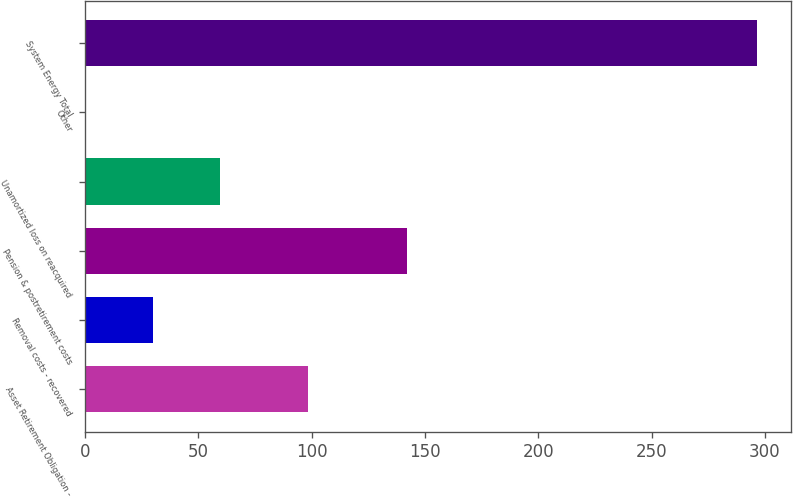Convert chart to OTSL. <chart><loc_0><loc_0><loc_500><loc_500><bar_chart><fcel>Asset Retirement Obligation -<fcel>Removal costs - recovered<fcel>Pension & postretirement costs<fcel>Unamortized loss on reacquired<fcel>Other<fcel>System Energy Total<nl><fcel>98.3<fcel>30.03<fcel>142<fcel>59.66<fcel>0.4<fcel>296.7<nl></chart> 